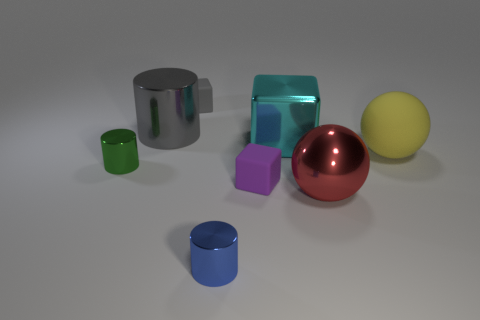Subtract all big metal cylinders. How many cylinders are left? 2 Add 1 metal cylinders. How many objects exist? 9 Subtract all cyan blocks. How many blocks are left? 2 Subtract all cylinders. How many objects are left? 5 Subtract 1 blocks. How many blocks are left? 2 Subtract all brown cubes. Subtract all green balls. How many cubes are left? 3 Subtract all small red matte balls. Subtract all large red objects. How many objects are left? 7 Add 7 large red objects. How many large red objects are left? 8 Add 8 small yellow metallic cylinders. How many small yellow metallic cylinders exist? 8 Subtract 1 yellow spheres. How many objects are left? 7 